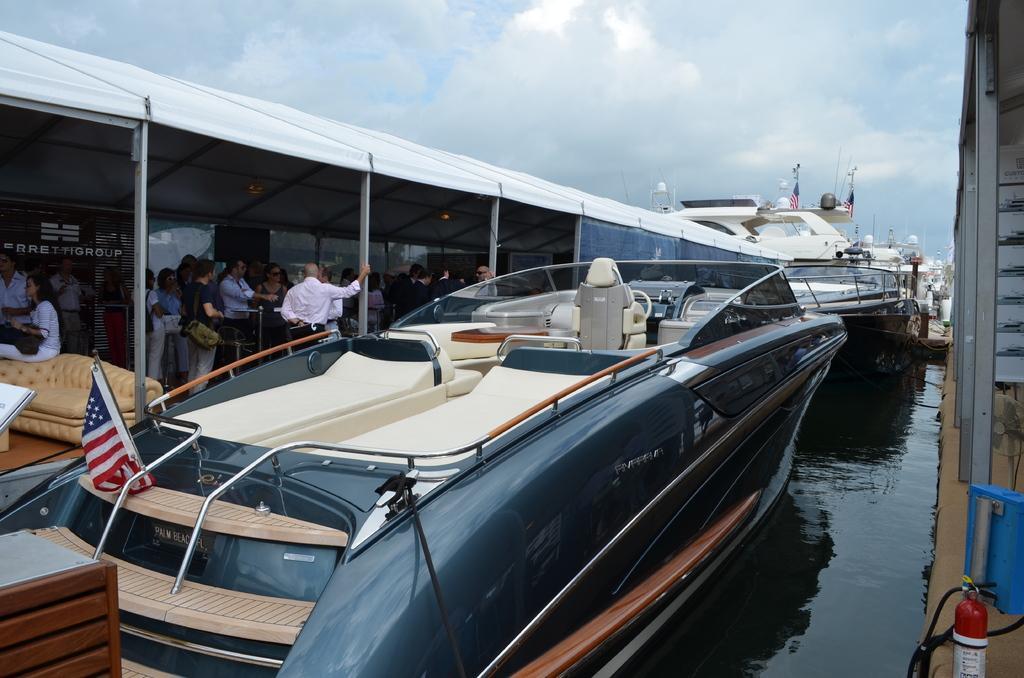In one or two sentences, can you explain what this image depicts? In this image I can see water and in it I can see few boats. I can also see people where few are sitting and rest all are standing. I can also see few flags and in background I can see clouds and the sky. I can also something is written over here. 